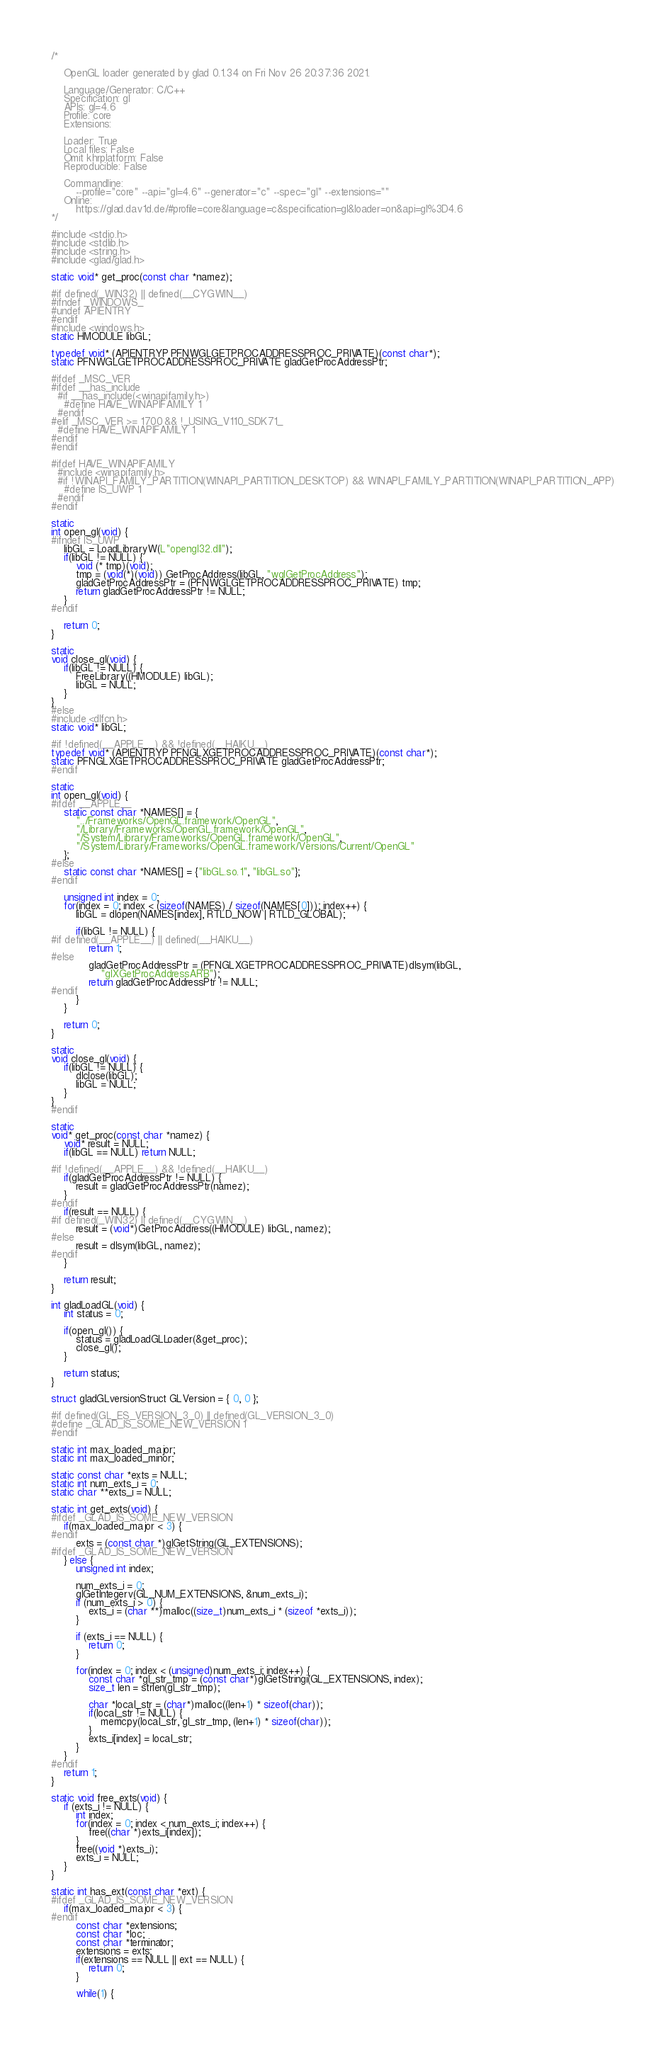<code> <loc_0><loc_0><loc_500><loc_500><_C_>/*

    OpenGL loader generated by glad 0.1.34 on Fri Nov 26 20:37:36 2021.

    Language/Generator: C/C++
    Specification: gl
    APIs: gl=4.6
    Profile: core
    Extensions:
        
    Loader: True
    Local files: False
    Omit khrplatform: False
    Reproducible: False

    Commandline:
        --profile="core" --api="gl=4.6" --generator="c" --spec="gl" --extensions=""
    Online:
        https://glad.dav1d.de/#profile=core&language=c&specification=gl&loader=on&api=gl%3D4.6
*/

#include <stdio.h>
#include <stdlib.h>
#include <string.h>
#include <glad/glad.h>

static void* get_proc(const char *namez);

#if defined(_WIN32) || defined(__CYGWIN__)
#ifndef _WINDOWS_
#undef APIENTRY
#endif
#include <windows.h>
static HMODULE libGL;

typedef void* (APIENTRYP PFNWGLGETPROCADDRESSPROC_PRIVATE)(const char*);
static PFNWGLGETPROCADDRESSPROC_PRIVATE gladGetProcAddressPtr;

#ifdef _MSC_VER
#ifdef __has_include
  #if __has_include(<winapifamily.h>)
    #define HAVE_WINAPIFAMILY 1
  #endif
#elif _MSC_VER >= 1700 && !_USING_V110_SDK71_
  #define HAVE_WINAPIFAMILY 1
#endif
#endif

#ifdef HAVE_WINAPIFAMILY
  #include <winapifamily.h>
  #if !WINAPI_FAMILY_PARTITION(WINAPI_PARTITION_DESKTOP) && WINAPI_FAMILY_PARTITION(WINAPI_PARTITION_APP)
    #define IS_UWP 1
  #endif
#endif

static
int open_gl(void) {
#ifndef IS_UWP
    libGL = LoadLibraryW(L"opengl32.dll");
    if(libGL != NULL) {
        void (* tmp)(void);
        tmp = (void(*)(void)) GetProcAddress(libGL, "wglGetProcAddress");
        gladGetProcAddressPtr = (PFNWGLGETPROCADDRESSPROC_PRIVATE) tmp;
        return gladGetProcAddressPtr != NULL;
    }
#endif

    return 0;
}

static
void close_gl(void) {
    if(libGL != NULL) {
        FreeLibrary((HMODULE) libGL);
        libGL = NULL;
    }
}
#else
#include <dlfcn.h>
static void* libGL;

#if !defined(__APPLE__) && !defined(__HAIKU__)
typedef void* (APIENTRYP PFNGLXGETPROCADDRESSPROC_PRIVATE)(const char*);
static PFNGLXGETPROCADDRESSPROC_PRIVATE gladGetProcAddressPtr;
#endif

static
int open_gl(void) {
#ifdef __APPLE__
    static const char *NAMES[] = {
        "../Frameworks/OpenGL.framework/OpenGL",
        "/Library/Frameworks/OpenGL.framework/OpenGL",
        "/System/Library/Frameworks/OpenGL.framework/OpenGL",
        "/System/Library/Frameworks/OpenGL.framework/Versions/Current/OpenGL"
    };
#else
    static const char *NAMES[] = {"libGL.so.1", "libGL.so"};
#endif

    unsigned int index = 0;
    for(index = 0; index < (sizeof(NAMES) / sizeof(NAMES[0])); index++) {
        libGL = dlopen(NAMES[index], RTLD_NOW | RTLD_GLOBAL);

        if(libGL != NULL) {
#if defined(__APPLE__) || defined(__HAIKU__)
            return 1;
#else
            gladGetProcAddressPtr = (PFNGLXGETPROCADDRESSPROC_PRIVATE)dlsym(libGL,
                "glXGetProcAddressARB");
            return gladGetProcAddressPtr != NULL;
#endif
        }
    }

    return 0;
}

static
void close_gl(void) {
    if(libGL != NULL) {
        dlclose(libGL);
        libGL = NULL;
    }
}
#endif

static
void* get_proc(const char *namez) {
    void* result = NULL;
    if(libGL == NULL) return NULL;

#if !defined(__APPLE__) && !defined(__HAIKU__)
    if(gladGetProcAddressPtr != NULL) {
        result = gladGetProcAddressPtr(namez);
    }
#endif
    if(result == NULL) {
#if defined(_WIN32) || defined(__CYGWIN__)
        result = (void*)GetProcAddress((HMODULE) libGL, namez);
#else
        result = dlsym(libGL, namez);
#endif
    }

    return result;
}

int gladLoadGL(void) {
    int status = 0;

    if(open_gl()) {
        status = gladLoadGLLoader(&get_proc);
        close_gl();
    }

    return status;
}

struct gladGLversionStruct GLVersion = { 0, 0 };

#if defined(GL_ES_VERSION_3_0) || defined(GL_VERSION_3_0)
#define _GLAD_IS_SOME_NEW_VERSION 1
#endif

static int max_loaded_major;
static int max_loaded_minor;

static const char *exts = NULL;
static int num_exts_i = 0;
static char **exts_i = NULL;

static int get_exts(void) {
#ifdef _GLAD_IS_SOME_NEW_VERSION
    if(max_loaded_major < 3) {
#endif
        exts = (const char *)glGetString(GL_EXTENSIONS);
#ifdef _GLAD_IS_SOME_NEW_VERSION
    } else {
        unsigned int index;

        num_exts_i = 0;
        glGetIntegerv(GL_NUM_EXTENSIONS, &num_exts_i);
        if (num_exts_i > 0) {
            exts_i = (char **)malloc((size_t)num_exts_i * (sizeof *exts_i));
        }

        if (exts_i == NULL) {
            return 0;
        }

        for(index = 0; index < (unsigned)num_exts_i; index++) {
            const char *gl_str_tmp = (const char*)glGetStringi(GL_EXTENSIONS, index);
            size_t len = strlen(gl_str_tmp);

            char *local_str = (char*)malloc((len+1) * sizeof(char));
            if(local_str != NULL) {
                memcpy(local_str, gl_str_tmp, (len+1) * sizeof(char));
            }
            exts_i[index] = local_str;
        }
    }
#endif
    return 1;
}

static void free_exts(void) {
    if (exts_i != NULL) {
        int index;
        for(index = 0; index < num_exts_i; index++) {
            free((char *)exts_i[index]);
        }
        free((void *)exts_i);
        exts_i = NULL;
    }
}

static int has_ext(const char *ext) {
#ifdef _GLAD_IS_SOME_NEW_VERSION
    if(max_loaded_major < 3) {
#endif
        const char *extensions;
        const char *loc;
        const char *terminator;
        extensions = exts;
        if(extensions == NULL || ext == NULL) {
            return 0;
        }

        while(1) {</code> 